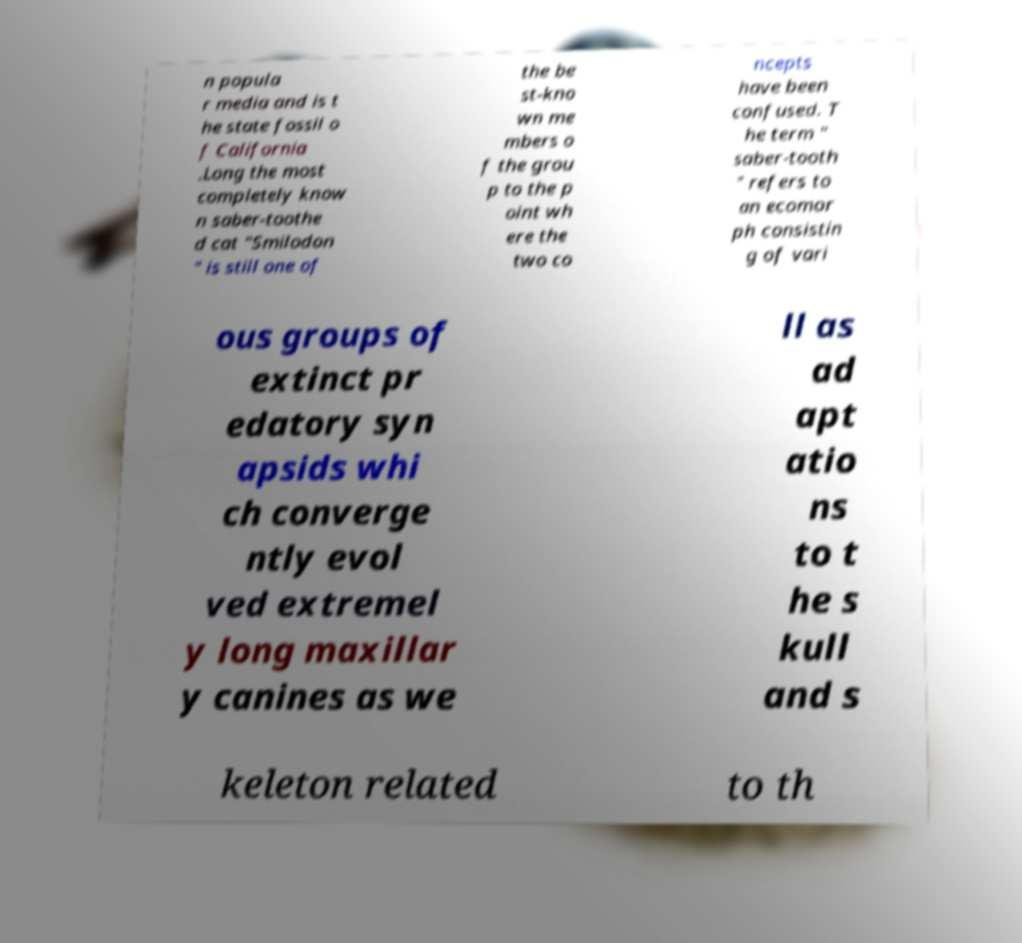I need the written content from this picture converted into text. Can you do that? n popula r media and is t he state fossil o f California .Long the most completely know n saber-toothe d cat "Smilodon " is still one of the be st-kno wn me mbers o f the grou p to the p oint wh ere the two co ncepts have been confused. T he term " saber-tooth " refers to an ecomor ph consistin g of vari ous groups of extinct pr edatory syn apsids whi ch converge ntly evol ved extremel y long maxillar y canines as we ll as ad apt atio ns to t he s kull and s keleton related to th 